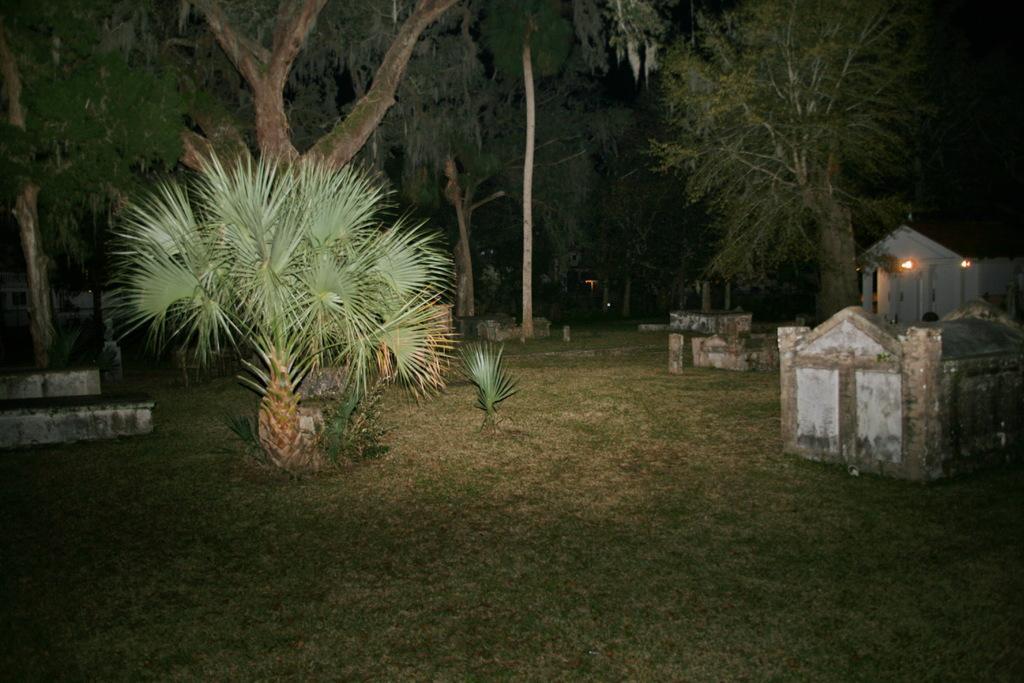In one or two sentences, can you explain what this image depicts? In this image there are few trees on the grassland. Right side there is a house having lights attached to the wall. There are few constructions on the grassland. 